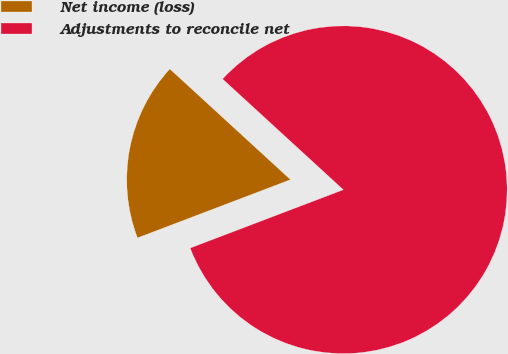Convert chart to OTSL. <chart><loc_0><loc_0><loc_500><loc_500><pie_chart><fcel>Net income (loss)<fcel>Adjustments to reconcile net<nl><fcel>17.6%<fcel>82.4%<nl></chart> 